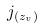<formula> <loc_0><loc_0><loc_500><loc_500>j _ { ( z _ { v } ) }</formula> 